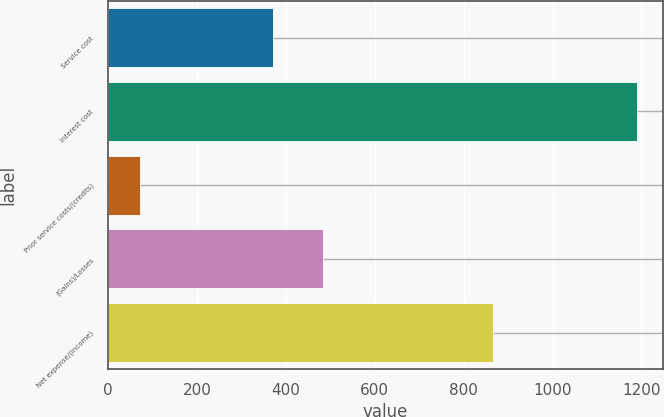<chart> <loc_0><loc_0><loc_500><loc_500><bar_chart><fcel>Service cost<fcel>Interest cost<fcel>Prior service costs/(credits)<fcel>(Gains)/Losses<fcel>Net expense/(income)<nl><fcel>372<fcel>1189<fcel>72<fcel>483.7<fcel>867<nl></chart> 